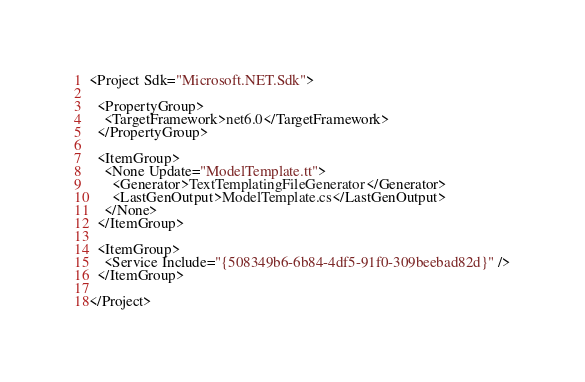<code> <loc_0><loc_0><loc_500><loc_500><_XML_><Project Sdk="Microsoft.NET.Sdk">

  <PropertyGroup>
    <TargetFramework>net6.0</TargetFramework>
  </PropertyGroup>

  <ItemGroup>
    <None Update="ModelTemplate.tt">
      <Generator>TextTemplatingFileGenerator</Generator>
      <LastGenOutput>ModelTemplate.cs</LastGenOutput>
    </None>
  </ItemGroup>

  <ItemGroup>
    <Service Include="{508349b6-6b84-4df5-91f0-309beebad82d}" />
  </ItemGroup>

</Project>
</code> 